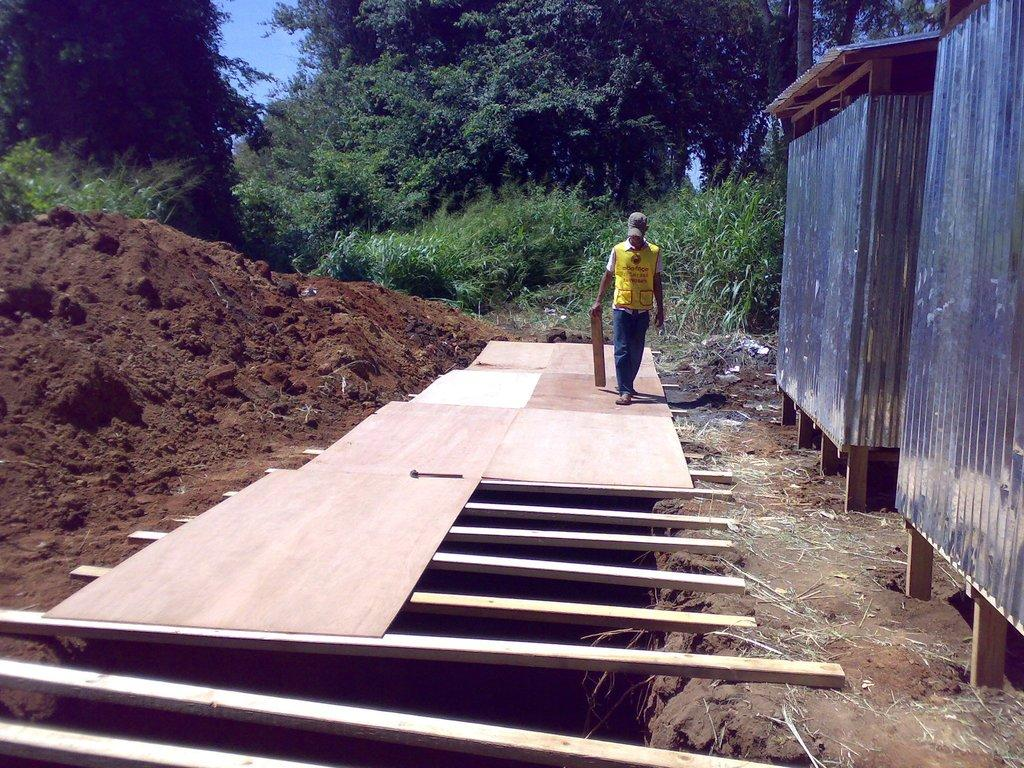Who or what is present in the image? There is a person in the image. What is the person standing or sitting on? The person is on a wooden surface. What is the person holding in their hand? The person is holding a wooden object. What type of wall can be seen in the image? There is a metal wall in the image. What type of ground is visible in the image? There is soil visible in the image. What type of vegetation is present in the image? There are trees in the image. What color is the sky in the image? The sky is blue in color. How many jokes are being told by the person's toes in the image? There is no mention of jokes or toes in the image, so it is not possible to determine how many jokes are being told by the person's toes. 